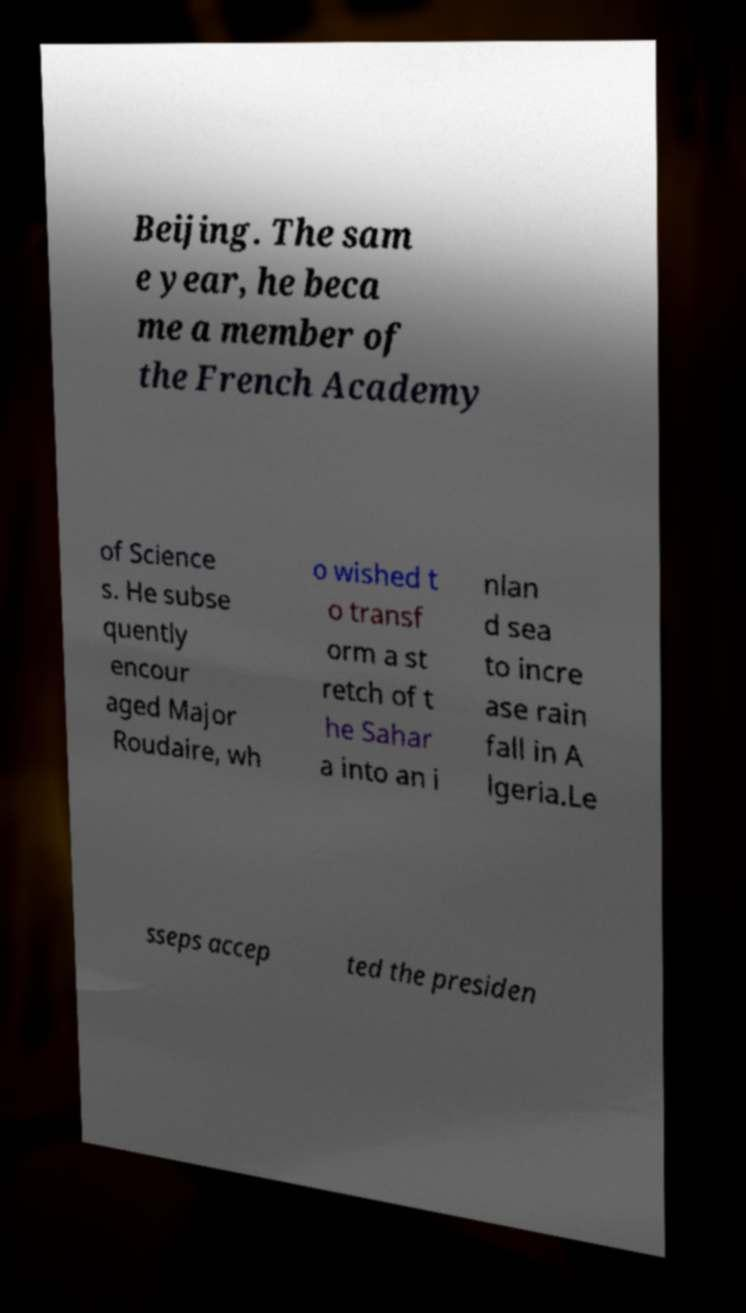I need the written content from this picture converted into text. Can you do that? Beijing. The sam e year, he beca me a member of the French Academy of Science s. He subse quently encour aged Major Roudaire, wh o wished t o transf orm a st retch of t he Sahar a into an i nlan d sea to incre ase rain fall in A lgeria.Le sseps accep ted the presiden 